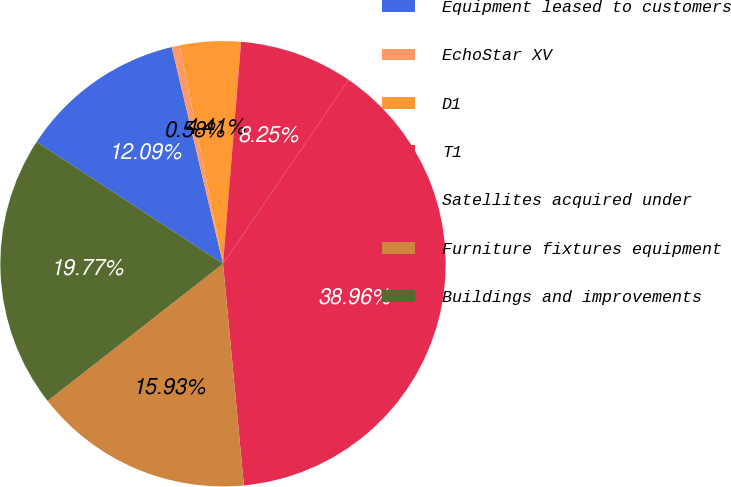Convert chart. <chart><loc_0><loc_0><loc_500><loc_500><pie_chart><fcel>Equipment leased to customers<fcel>EchoStar XV<fcel>D1<fcel>T1<fcel>Satellites acquired under<fcel>Furniture fixtures equipment<fcel>Buildings and improvements<nl><fcel>12.09%<fcel>0.58%<fcel>4.41%<fcel>8.25%<fcel>38.96%<fcel>15.93%<fcel>19.77%<nl></chart> 